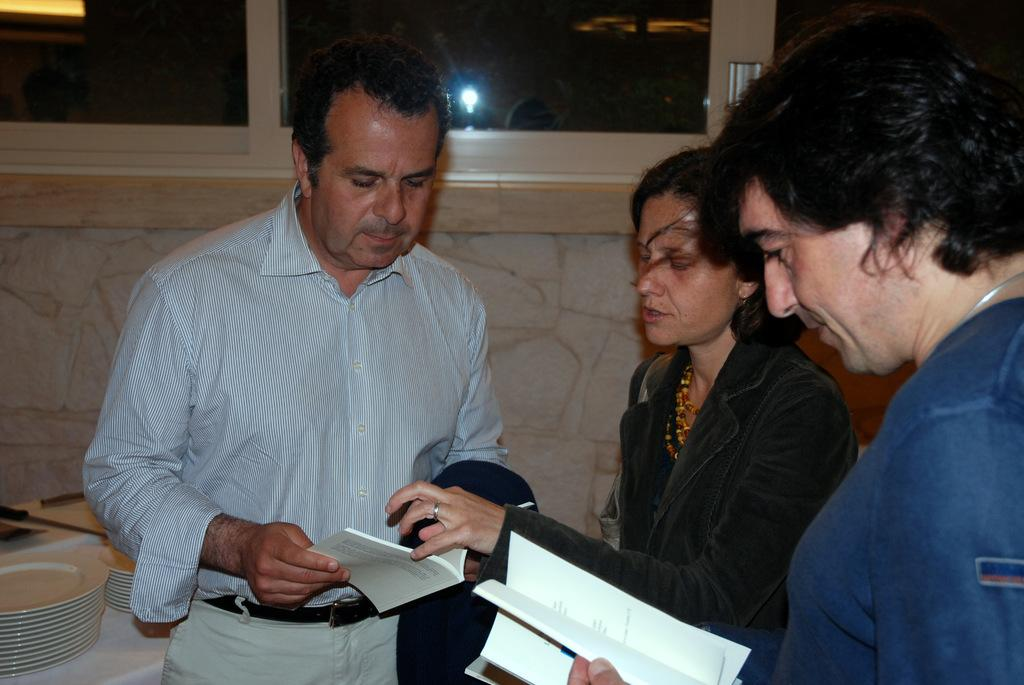How many people are in the image? There are two men and two women in the image. What are the two men holding? The two men are holding books. What can be seen on the table in the image? There are planets depicted on a table. What is visible in the background of the image? There is a wall and glass windows in the background of the image. What historical event is being discussed by the people in the image? There is no indication of a historical event being discussed in the image. The image only shows two men holding books, two women, planets on a table, a wall, and glass windows in the background. 